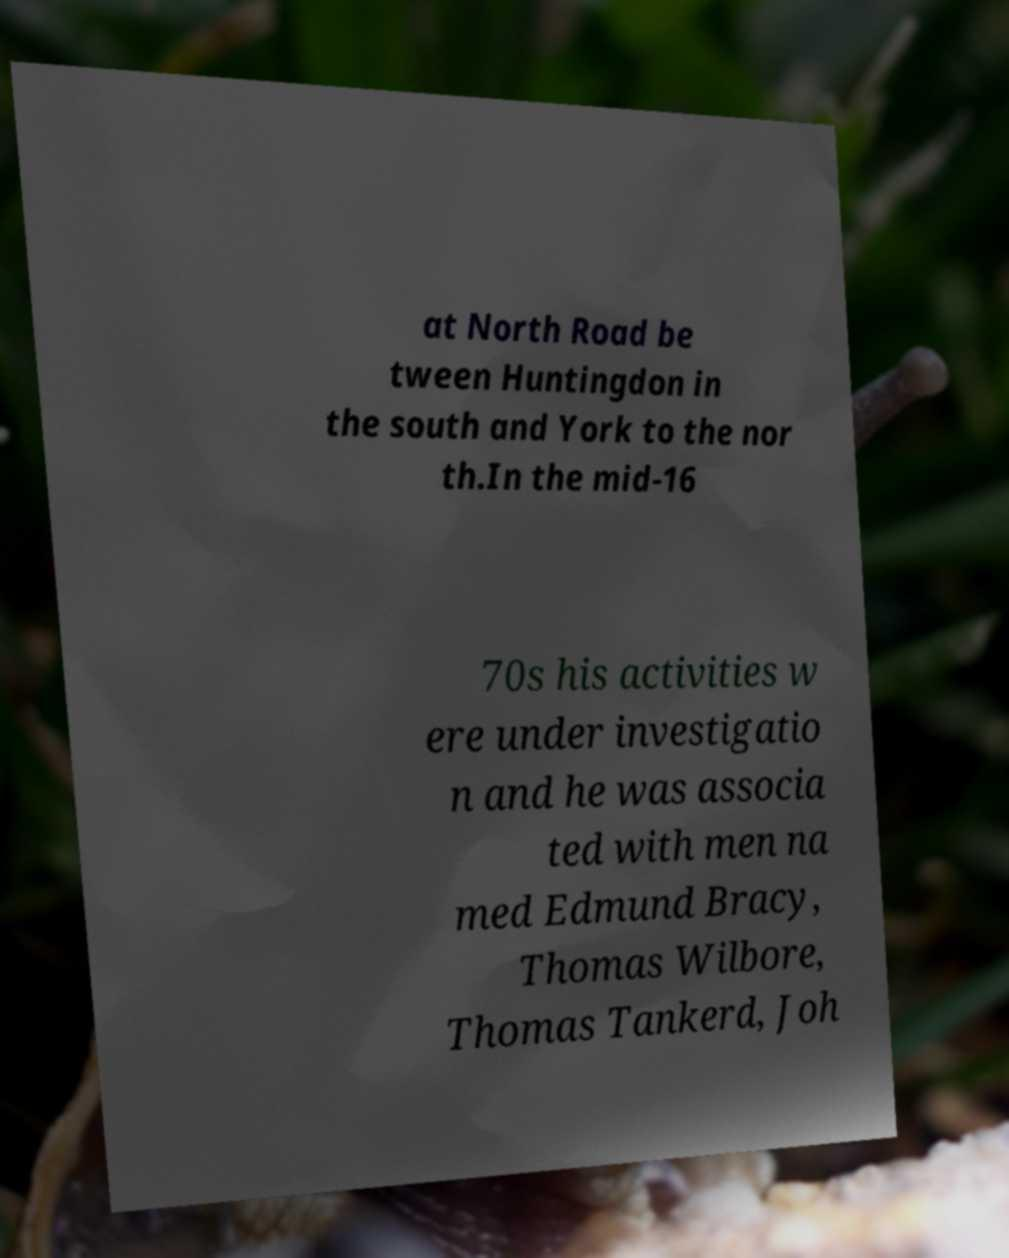Could you extract and type out the text from this image? at North Road be tween Huntingdon in the south and York to the nor th.In the mid-16 70s his activities w ere under investigatio n and he was associa ted with men na med Edmund Bracy, Thomas Wilbore, Thomas Tankerd, Joh 